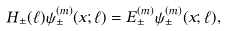Convert formula to latex. <formula><loc_0><loc_0><loc_500><loc_500>H _ { \pm } ( \ell ) \psi _ { \pm } ^ { ( m ) } ( x ; \ell ) = E ^ { ( m ) } _ { \pm } \psi _ { \pm } ^ { ( m ) } ( x ; \ell ) ,</formula> 